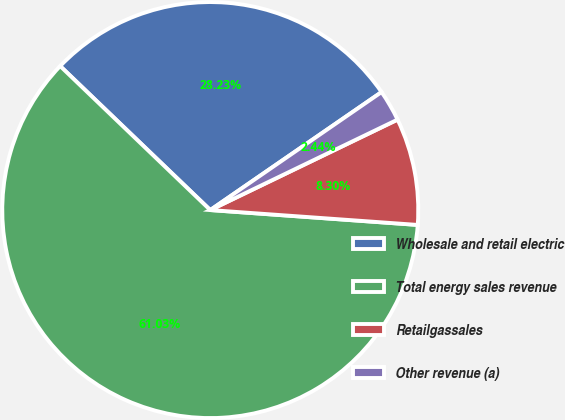Convert chart. <chart><loc_0><loc_0><loc_500><loc_500><pie_chart><fcel>Wholesale and retail electric<fcel>Total energy sales revenue<fcel>Retailgassales<fcel>Other revenue (a)<nl><fcel>28.23%<fcel>61.03%<fcel>8.3%<fcel>2.44%<nl></chart> 